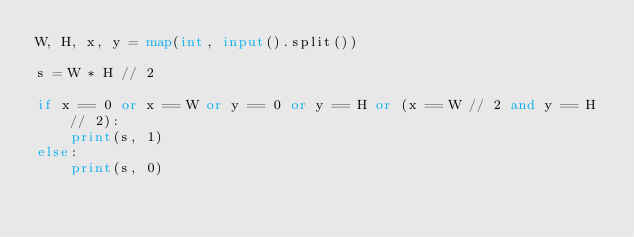<code> <loc_0><loc_0><loc_500><loc_500><_Python_>W, H, x, y = map(int, input().split())

s = W * H // 2

if x == 0 or x == W or y == 0 or y == H or (x == W // 2 and y == H // 2):
    print(s, 1)
else:
    print(s, 0)
</code> 